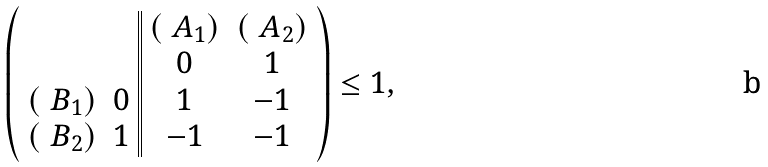Convert formula to latex. <formula><loc_0><loc_0><loc_500><loc_500>\left ( \begin{array} { c c | | c c } & & ( \ A _ { 1 } ) & ( \ A _ { 2 } ) \\ & & 0 & 1 \\ ( \ B _ { 1 } ) & 0 & 1 & - 1 \\ ( \ B _ { 2 } ) & 1 & - 1 & - 1 \end{array} \right ) \leq 1 ,</formula> 